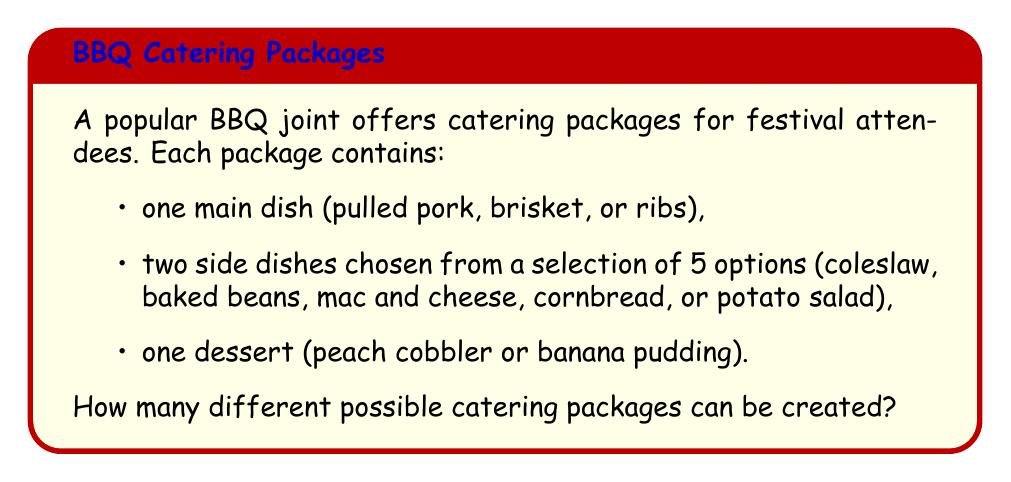Help me with this question. Let's break this down step-by-step:

1. Main dish options:
   There are 3 choices for the main dish (pulled pork, brisket, or ribs).

2. Side dish options:
   We need to choose 2 side dishes out of 5 options. This is a combination problem.
   We can calculate this using the combination formula:
   $$\binom{5}{2} = \frac{5!}{2!(5-2)!} = \frac{5 \cdot 4}{2 \cdot 1} = 10$$

3. Dessert options:
   There are 2 choices for dessert (peach cobbler or banana pudding).

4. Total number of possible packages:
   To find the total number of possible packages, we multiply the number of options for each component:
   $$ 3 \cdot 10 \cdot 2 = 60 $$

Therefore, there are 60 different possible catering packages that can be created.
Answer: 60 